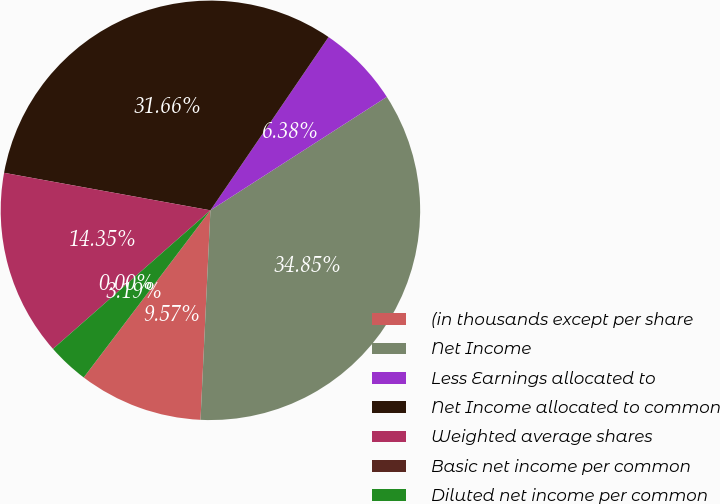Convert chart to OTSL. <chart><loc_0><loc_0><loc_500><loc_500><pie_chart><fcel>(in thousands except per share<fcel>Net Income<fcel>Less Earnings allocated to<fcel>Net Income allocated to common<fcel>Weighted average shares<fcel>Basic net income per common<fcel>Diluted net income per common<nl><fcel>9.57%<fcel>34.85%<fcel>6.38%<fcel>31.66%<fcel>14.35%<fcel>0.0%<fcel>3.19%<nl></chart> 